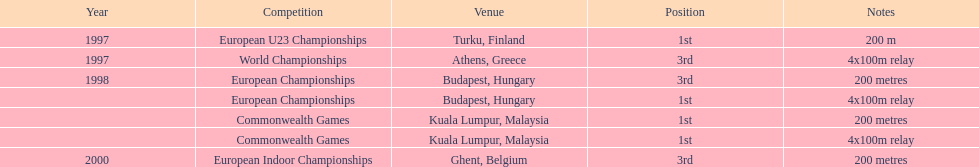Give me the full table as a dictionary. {'header': ['Year', 'Competition', 'Venue', 'Position', 'Notes'], 'rows': [['1997', 'European U23 Championships', 'Turku, Finland', '1st', '200 m'], ['1997', 'World Championships', 'Athens, Greece', '3rd', '4x100m relay'], ['1998', 'European Championships', 'Budapest, Hungary', '3rd', '200 metres'], ['', 'European Championships', 'Budapest, Hungary', '1st', '4x100m relay'], ['', 'Commonwealth Games', 'Kuala Lumpur, Malaysia', '1st', '200 metres'], ['', 'Commonwealth Games', 'Kuala Lumpur, Malaysia', '1st', '4x100m relay'], ['2000', 'European Indoor Championships', 'Ghent, Belgium', '3rd', '200 metres']]} What was the only competition won in belgium? European Indoor Championships. 